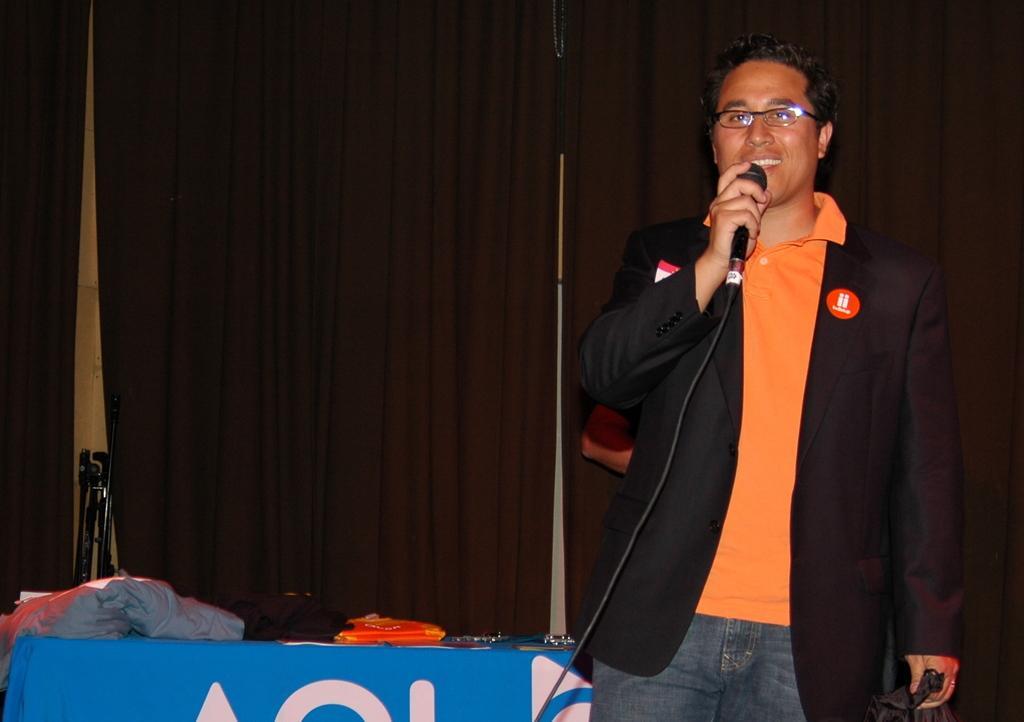Could you give a brief overview of what you see in this image? This image consists of a man wearing black suit is talking in a mic. To the left, there is a table on which there is a blue color cloth. In the background, there are curtains in brown color. 